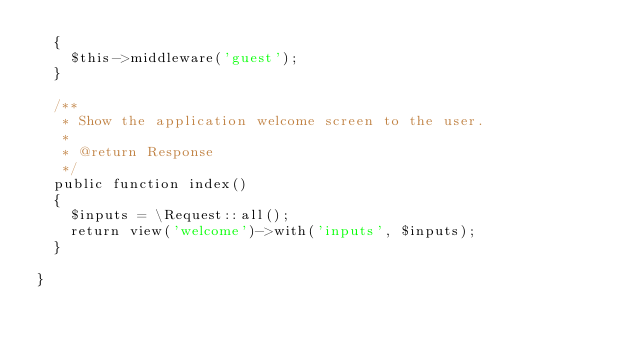Convert code to text. <code><loc_0><loc_0><loc_500><loc_500><_PHP_>	{
		$this->middleware('guest');
	}

	/**
	 * Show the application welcome screen to the user.
	 *
	 * @return Response
	 */
	public function index()
	{
		$inputs = \Request::all();
		return view('welcome')->with('inputs', $inputs);
	}

}
</code> 